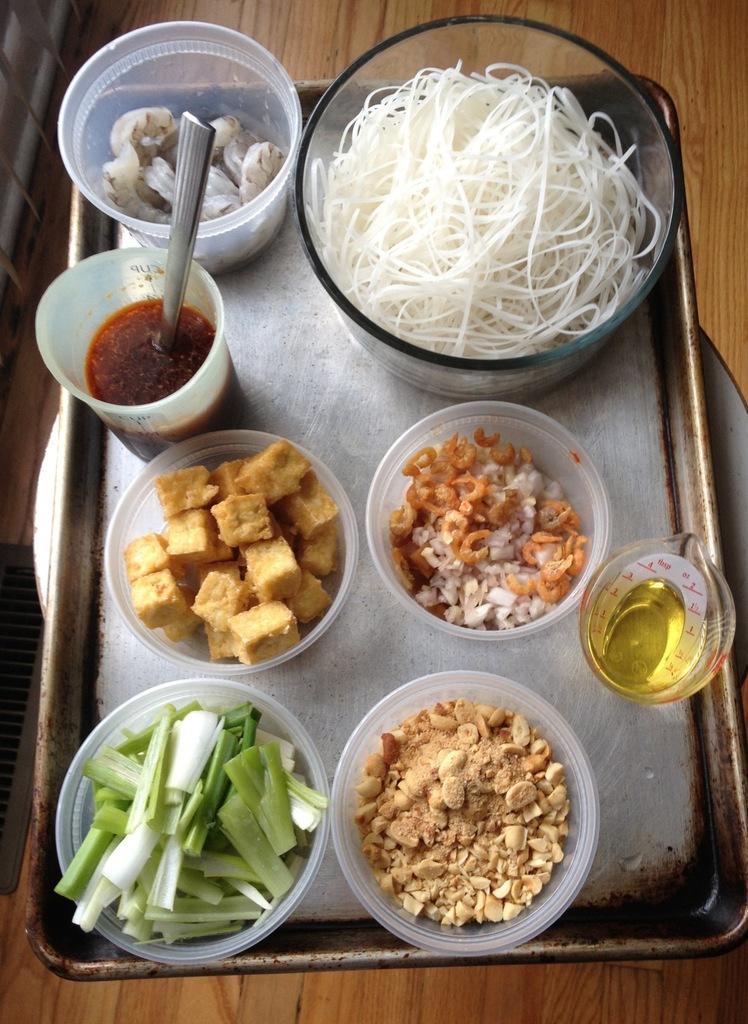How would you summarize this image in a sentence or two? In this picture we can see a plate in which many bowls are kept. These seem to be like the ingredients of a noodle recipe. 